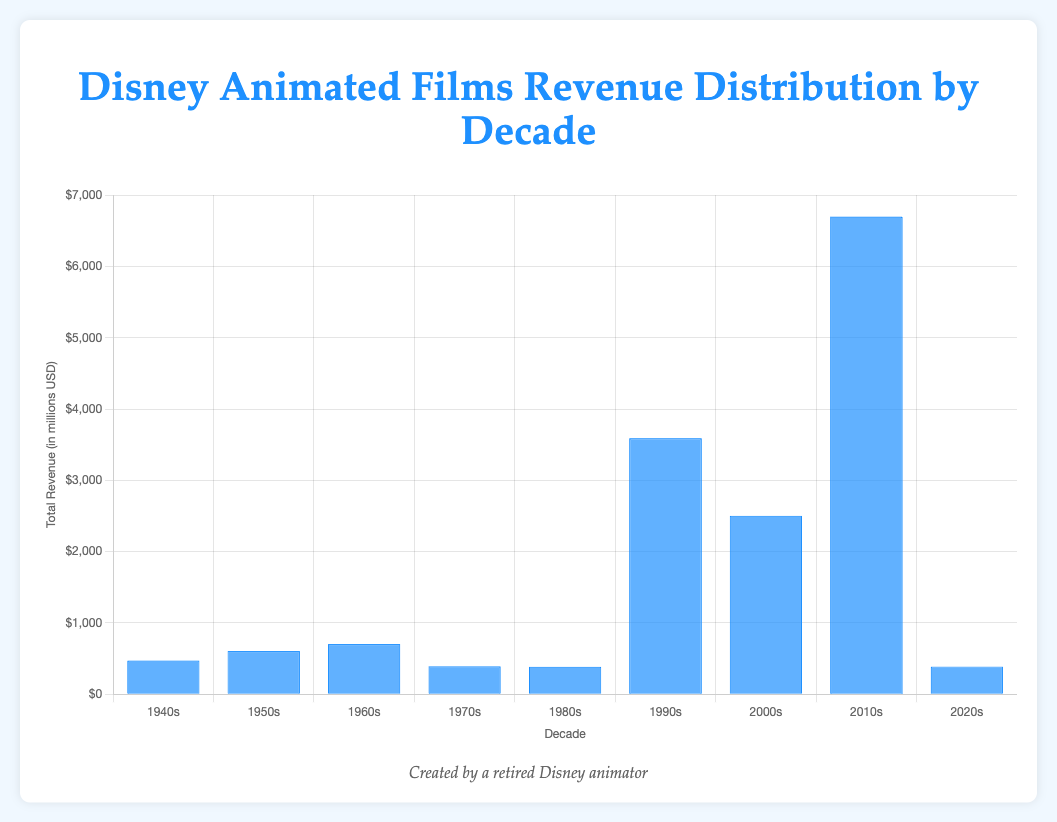Which decade generated the highest total revenue? Observe the heights of the bars for each decade and identify the tallest one. The tallest bar represents the decade with the highest total revenue.
Answer: 2010s Which decade had the lowest revenue? Observe the heights of the bars for each decade and identify the shortest one. The shortest bar represents the decade with the lowest total revenue.
Answer: 2020s What is the total revenue of Disney animated films in the 1950s? Sum the revenues of all films listed for the 1950s: (263.6 + 15.2 + 87.4 + 187.3 + 51.6) = 605.1 million USD.
Answer: 605.1 million USD Which two decades combined have the highest total revenue? Add the total revenues of each decade and find the two decades with the highest combined total. The 2010s and 1990s have (6517.9 + 3589.4) = 10087.3 million USD.
Answer: 2010s and 1990s By how much does the revenue of the 2010s exceed that of the 2000s? Subtract the total revenue of the 2000s from the total revenue of the 2010s: 6517.9 - 2498.9 = 4019 million USD.
Answer: 4019 million USD What is the average revenue per decade from the 1940s to 2020s? Sum the total revenues of all decades ((473.6 + 605.1 + 703.2 + 392.1 + 385.4 + 3589.4 + 2498.9 + 6517.9 + 386.8) = 14152.4 million USD) and divide by the number of decades (9): 14152.4 / 9 = 1572.5 million USD.
Answer: 1572.5 million USD Which decade had the most significant increase in revenue compared to the previous decade? Calculate the revenue difference between consecutive decades and identify the largest increase. The largest increase is from the 2000s to the 2010s: 6517.9 - 2498.9 = 4019 million USD.
Answer: 2000s to 2010s How much revenue did the 1960s generate compared to the 1940s? Subtract the total revenue of the 1940s from the total revenue of the 1960s: 703.2 - 473.6 = 229.6 million USD.
Answer: 229.6 million USD Which decade has a total revenue closest to the average revenue per decade? Compare the total revenues of each decade to the average revenue per decade (1572.5 million USD) and find the closest value. The 2000s at 2498.9 million USD are closest to the average.
Answer: 2000s What is the sum of the total revenues of the 1980s and 1940s? Add the total revenues of the 1980s and 1940s: 385.4 + 473.6 = 859 million USD.
Answer: 859 million USD 